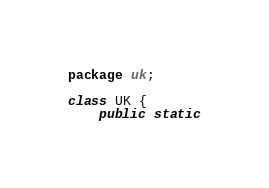Convert code to text. <code><loc_0><loc_0><loc_500><loc_500><_Haxe_>package uk;

class UK {
    public static</code> 